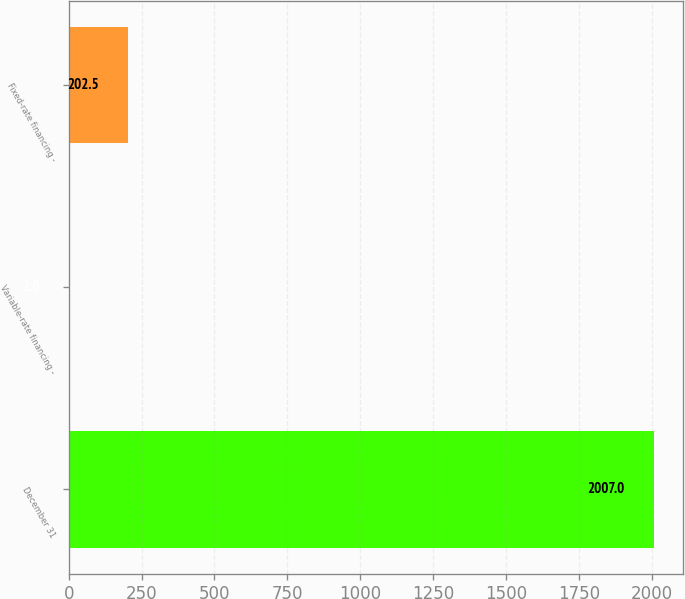Convert chart to OTSL. <chart><loc_0><loc_0><loc_500><loc_500><bar_chart><fcel>December 31<fcel>Variable-rate financing -<fcel>Fixed-rate financing -<nl><fcel>2007<fcel>2<fcel>202.5<nl></chart> 